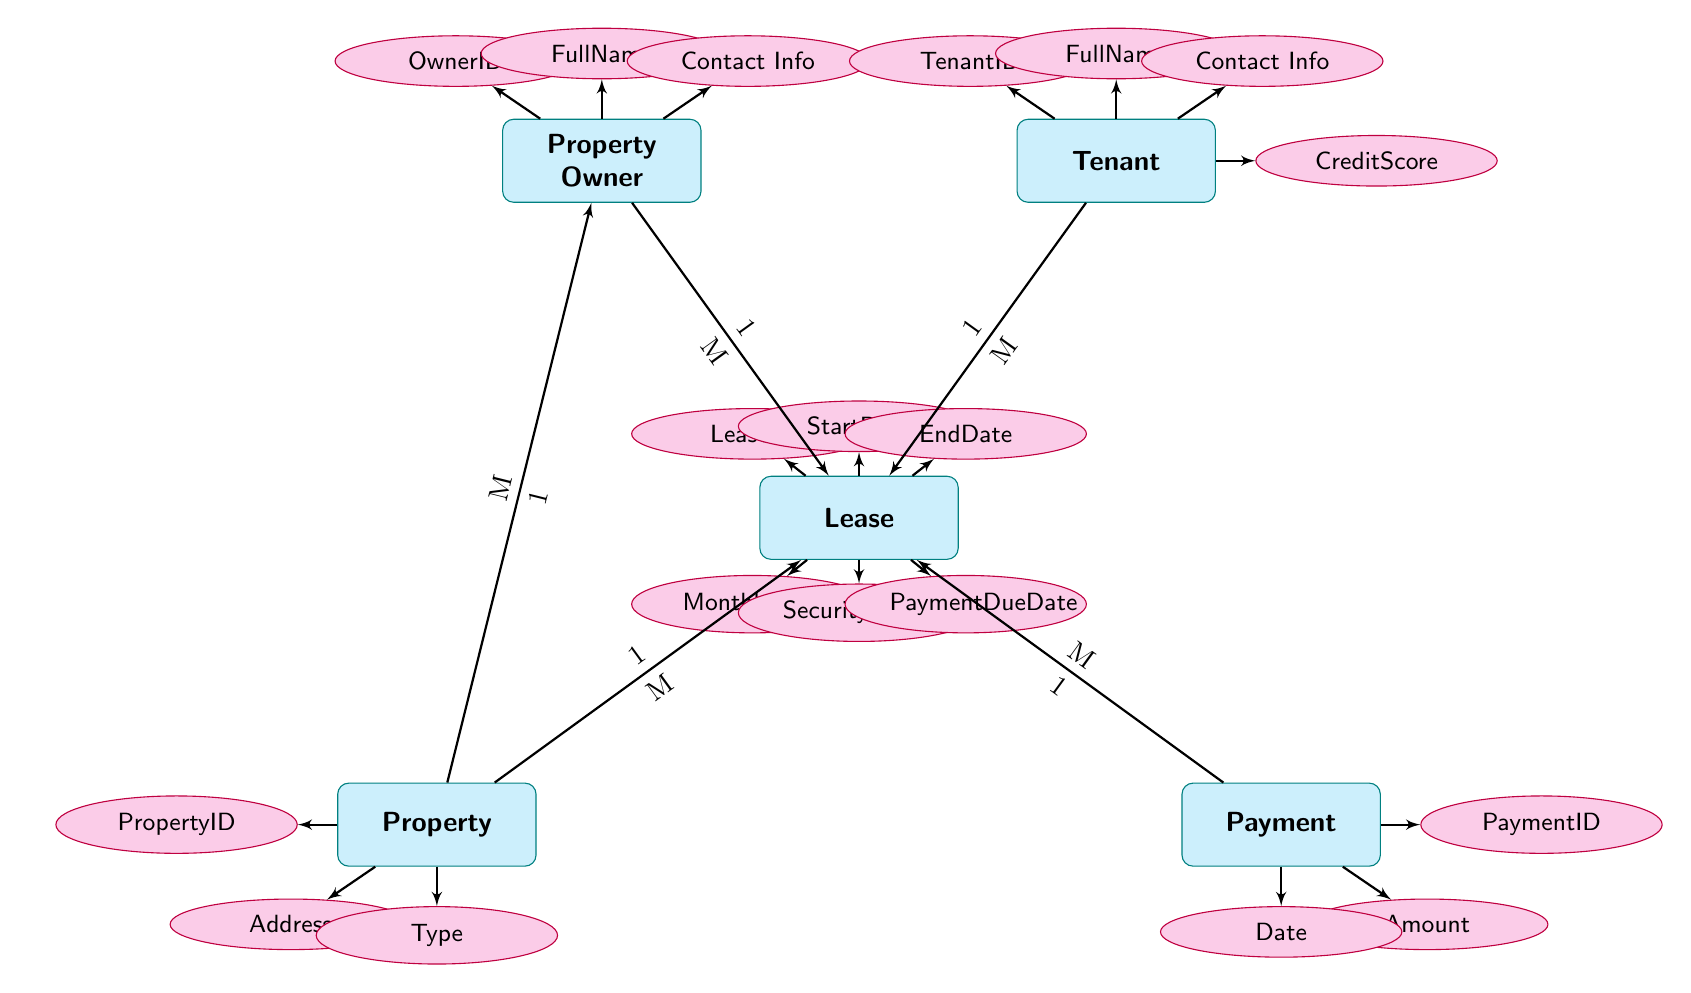What entities are present in the diagram? The diagram features five entities: Property Owner, Tenant, Lease, Property, and Payment.
Answer: Property Owner, Tenant, Lease, Property, Payment How many attributes does the Lease entity have? The Lease entity is associated with six attributes: LeaseID, StartDate, EndDate, MonthlyRent, SecurityDeposit, and PaymentDueDate.
Answer: 6 What relationship type exists between Lease and Tenant? The diagram shows a many-to-one relationship from Lease to Tenant, indicating that multiple leases can be associated with a single tenant.
Answer: M to 1 How many tenants can be associated with a single lease? According to the diagram, each lease can be associated with one tenant, so the quantity is one.
Answer: 1 What is the Payment entity related to? The Payment entity is related to the Lease entity through the "AppliesTo" relationship, indicating that multiple payments can apply to a single lease.
Answer: Lease How many properties can a single Property Owner own? The diagram illustrates a many-to-one relationship between Property and Property Owner, suggesting that a single property owner may own multiple properties.
Answer: M Is it possible for multiple tenants to occupy one property? Given that both Tenant and Property entities have a one-to-many relationship with Lease, it implies that multiple tenants can lease the same property through different leases.
Answer: Yes What is the nature of the relationship between Lease and Payment? The relationship between Lease and Payment is characterized as many-to-one, indicating that multiple payments can apply to one lease.
Answer: M to 1 What attribute in the Tenant entity indicates financial reliability? The CreditScore attribute in the Tenant entity indicates the tenant's financial reliability.
Answer: CreditScore 